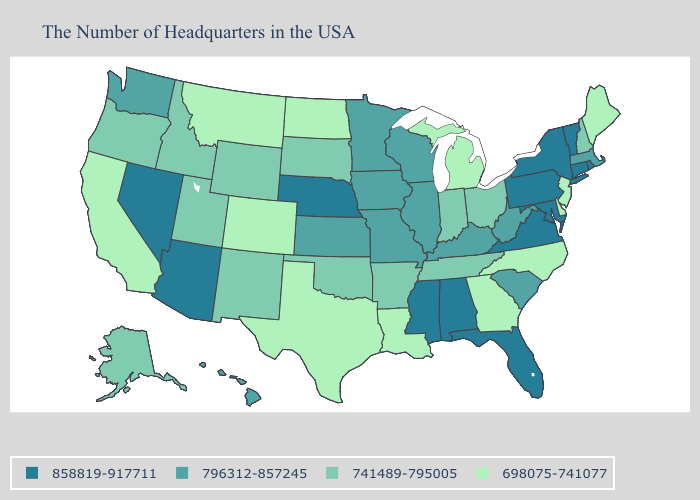How many symbols are there in the legend?
Give a very brief answer. 4. What is the highest value in states that border Kansas?
Be succinct. 858819-917711. Does South Dakota have the highest value in the USA?
Write a very short answer. No. Which states have the highest value in the USA?
Concise answer only. Rhode Island, Vermont, Connecticut, New York, Maryland, Pennsylvania, Virginia, Florida, Alabama, Mississippi, Nebraska, Arizona, Nevada. Name the states that have a value in the range 698075-741077?
Keep it brief. Maine, New Jersey, Delaware, North Carolina, Georgia, Michigan, Louisiana, Texas, North Dakota, Colorado, Montana, California. What is the value of Wyoming?
Give a very brief answer. 741489-795005. What is the lowest value in states that border Delaware?
Be succinct. 698075-741077. Which states have the lowest value in the South?
Give a very brief answer. Delaware, North Carolina, Georgia, Louisiana, Texas. What is the value of Wyoming?
Answer briefly. 741489-795005. Does Idaho have the lowest value in the USA?
Concise answer only. No. Does Colorado have the same value as New Jersey?
Write a very short answer. Yes. Which states hav the highest value in the South?
Answer briefly. Maryland, Virginia, Florida, Alabama, Mississippi. What is the value of North Dakota?
Quick response, please. 698075-741077. Among the states that border Oklahoma , does Texas have the highest value?
Quick response, please. No. Name the states that have a value in the range 698075-741077?
Write a very short answer. Maine, New Jersey, Delaware, North Carolina, Georgia, Michigan, Louisiana, Texas, North Dakota, Colorado, Montana, California. 